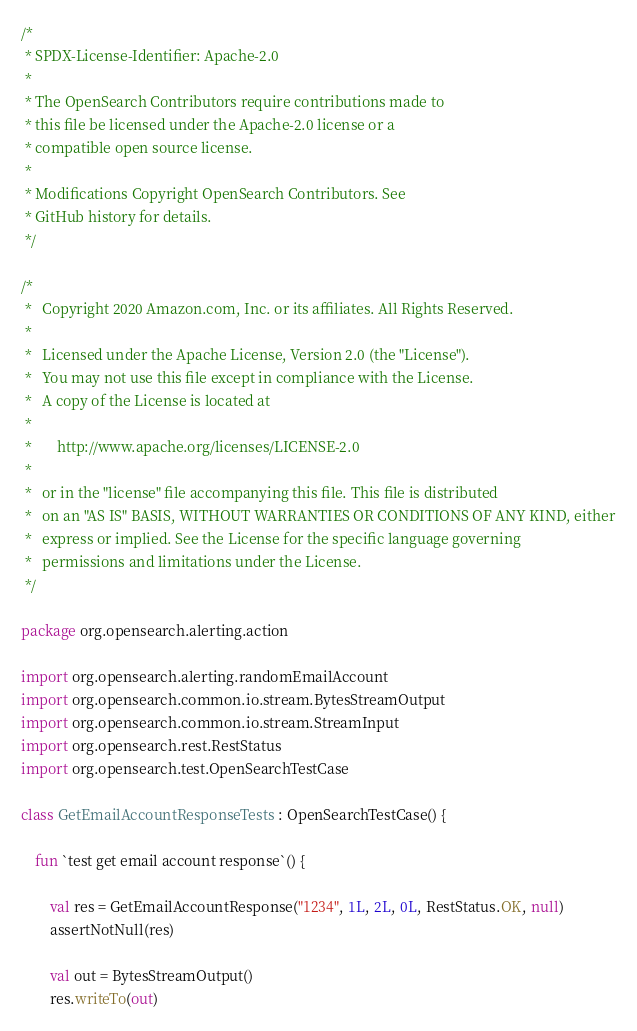<code> <loc_0><loc_0><loc_500><loc_500><_Kotlin_>/*
 * SPDX-License-Identifier: Apache-2.0
 *
 * The OpenSearch Contributors require contributions made to
 * this file be licensed under the Apache-2.0 license or a
 * compatible open source license.
 *
 * Modifications Copyright OpenSearch Contributors. See
 * GitHub history for details.
 */

/*
 *   Copyright 2020 Amazon.com, Inc. or its affiliates. All Rights Reserved.
 *
 *   Licensed under the Apache License, Version 2.0 (the "License").
 *   You may not use this file except in compliance with the License.
 *   A copy of the License is located at
 *
 *       http://www.apache.org/licenses/LICENSE-2.0
 *
 *   or in the "license" file accompanying this file. This file is distributed
 *   on an "AS IS" BASIS, WITHOUT WARRANTIES OR CONDITIONS OF ANY KIND, either
 *   express or implied. See the License for the specific language governing
 *   permissions and limitations under the License.
 */

package org.opensearch.alerting.action

import org.opensearch.alerting.randomEmailAccount
import org.opensearch.common.io.stream.BytesStreamOutput
import org.opensearch.common.io.stream.StreamInput
import org.opensearch.rest.RestStatus
import org.opensearch.test.OpenSearchTestCase

class GetEmailAccountResponseTests : OpenSearchTestCase() {

    fun `test get email account response`() {

        val res = GetEmailAccountResponse("1234", 1L, 2L, 0L, RestStatus.OK, null)
        assertNotNull(res)

        val out = BytesStreamOutput()
        res.writeTo(out)</code> 